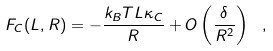<formula> <loc_0><loc_0><loc_500><loc_500>F _ { C } ( L , R ) = - \frac { k _ { B } T L \kappa _ { C } } { R } + O \left ( \frac { \delta } { R ^ { 2 } } \right ) \ ,</formula> 